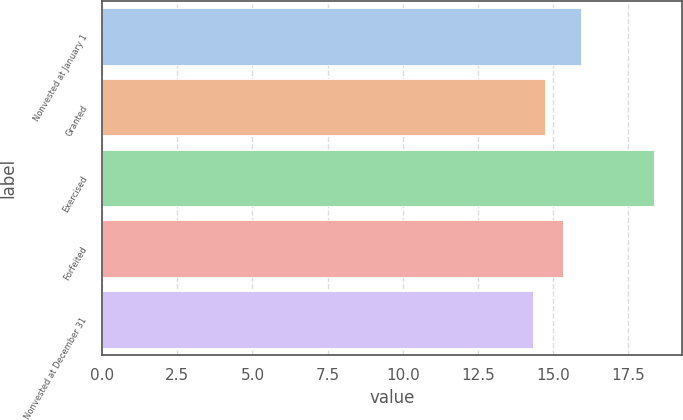Convert chart to OTSL. <chart><loc_0><loc_0><loc_500><loc_500><bar_chart><fcel>Nonvested at January 1<fcel>Granted<fcel>Exercised<fcel>Forfeited<fcel>Nonvested at December 31<nl><fcel>15.95<fcel>14.72<fcel>18.37<fcel>15.35<fcel>14.32<nl></chart> 